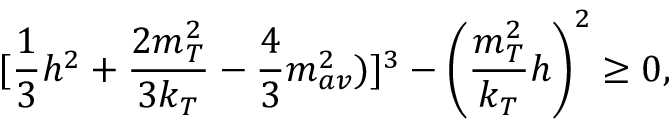Convert formula to latex. <formula><loc_0><loc_0><loc_500><loc_500>[ { \frac { 1 } { 3 } } h ^ { 2 } + { \frac { 2 m _ { T } ^ { 2 } } { 3 k _ { T } } } - { \frac { 4 } { 3 } } m _ { a v } ^ { 2 } ) ] ^ { 3 } - \left ( { \frac { m _ { T } ^ { 2 } } { k _ { T } } } h \right ) ^ { 2 } \geq 0 ,</formula> 